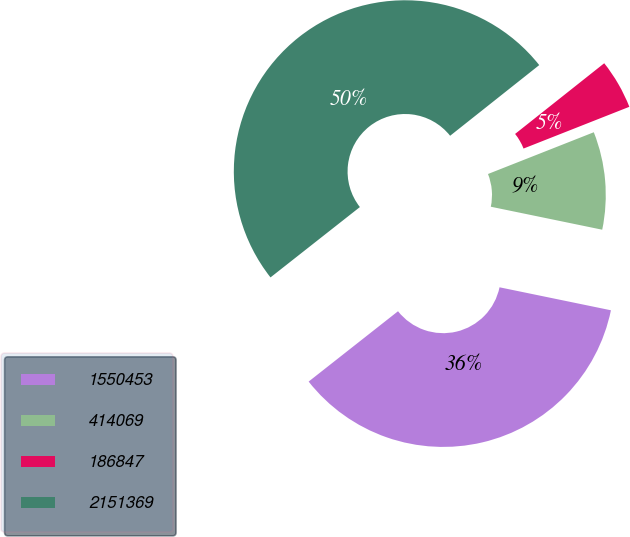Convert chart to OTSL. <chart><loc_0><loc_0><loc_500><loc_500><pie_chart><fcel>1550453<fcel>414069<fcel>186847<fcel>2151369<nl><fcel>36.15%<fcel>9.22%<fcel>4.69%<fcel>49.94%<nl></chart> 